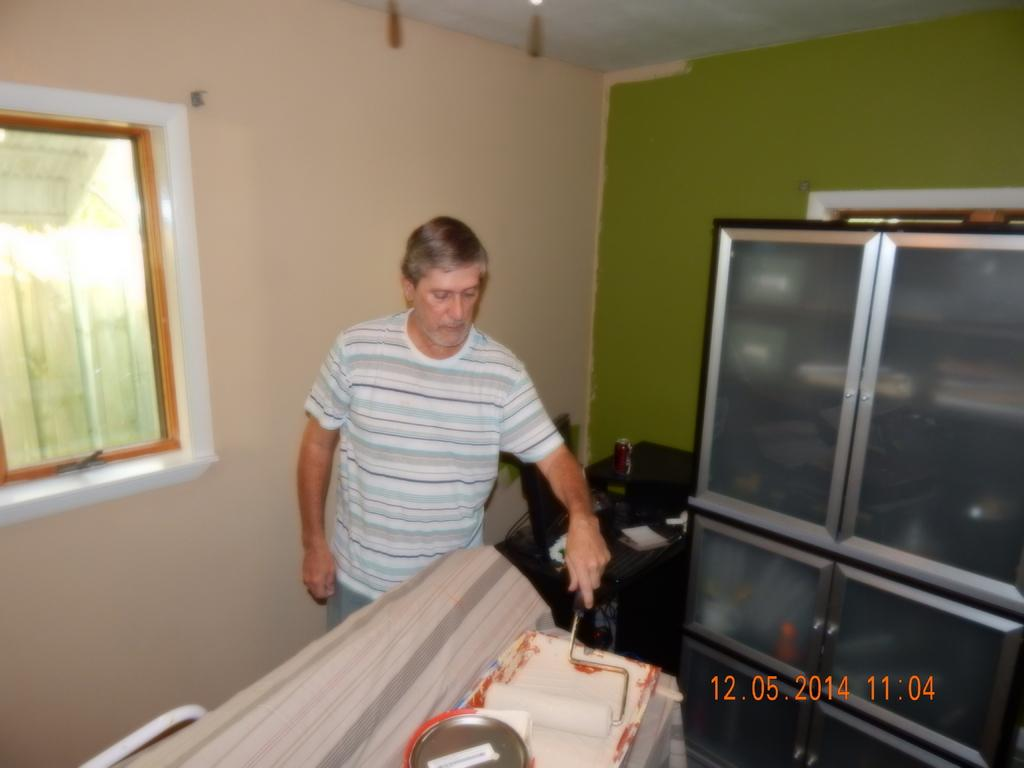What is the man in the image holding? The man is holding a painting roller. What can be seen in the background of the image? There are windows, walls, and a cupboard in the background of the image. Are there any other objects visible in the background? Yes, there are objects on a side table in the background of the image. How much sugar is in the cupboard in the image? There is no information about sugar in the image, as it focuses on the man holding a painting roller and the background elements. 